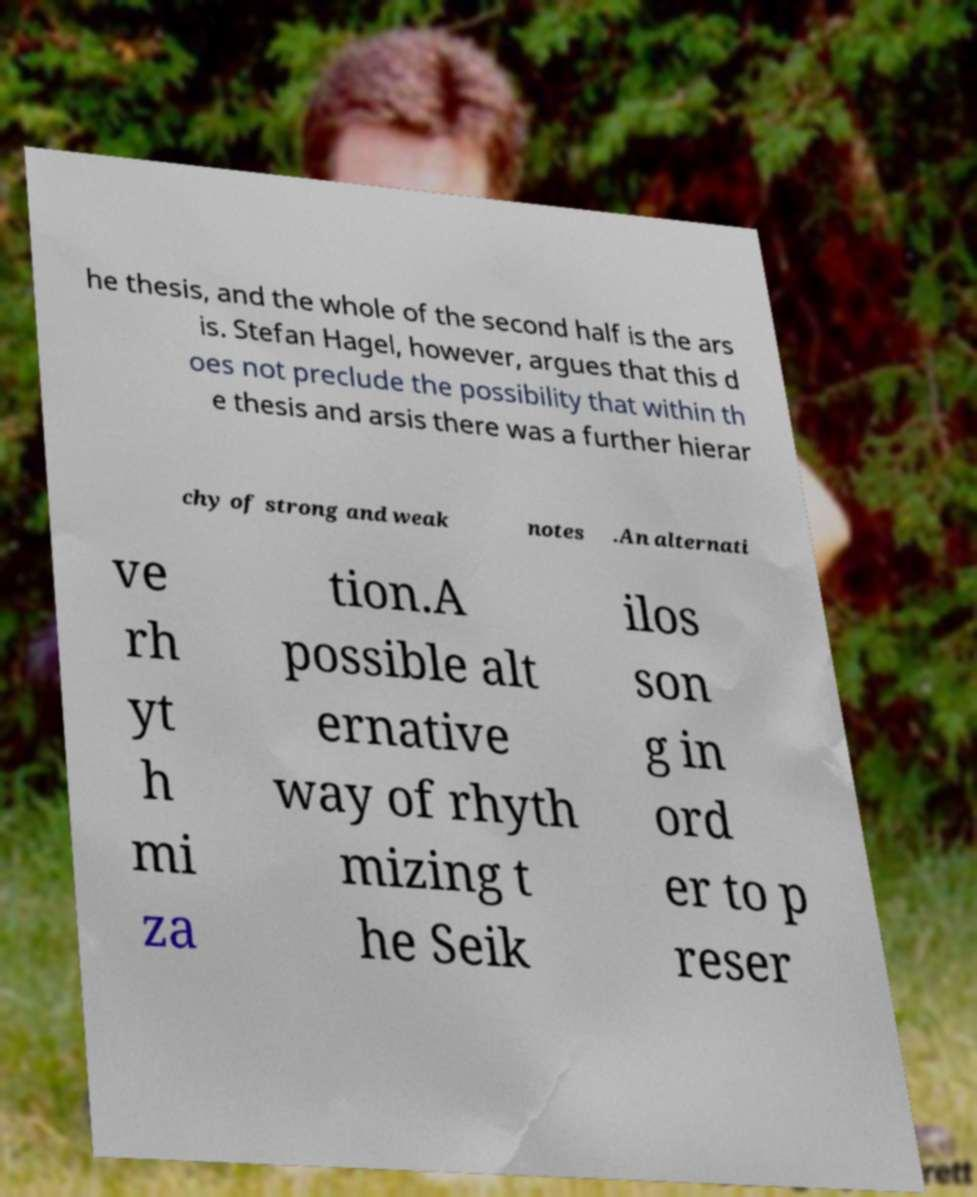What messages or text are displayed in this image? I need them in a readable, typed format. he thesis, and the whole of the second half is the ars is. Stefan Hagel, however, argues that this d oes not preclude the possibility that within th e thesis and arsis there was a further hierar chy of strong and weak notes .An alternati ve rh yt h mi za tion.A possible alt ernative way of rhyth mizing t he Seik ilos son g in ord er to p reser 